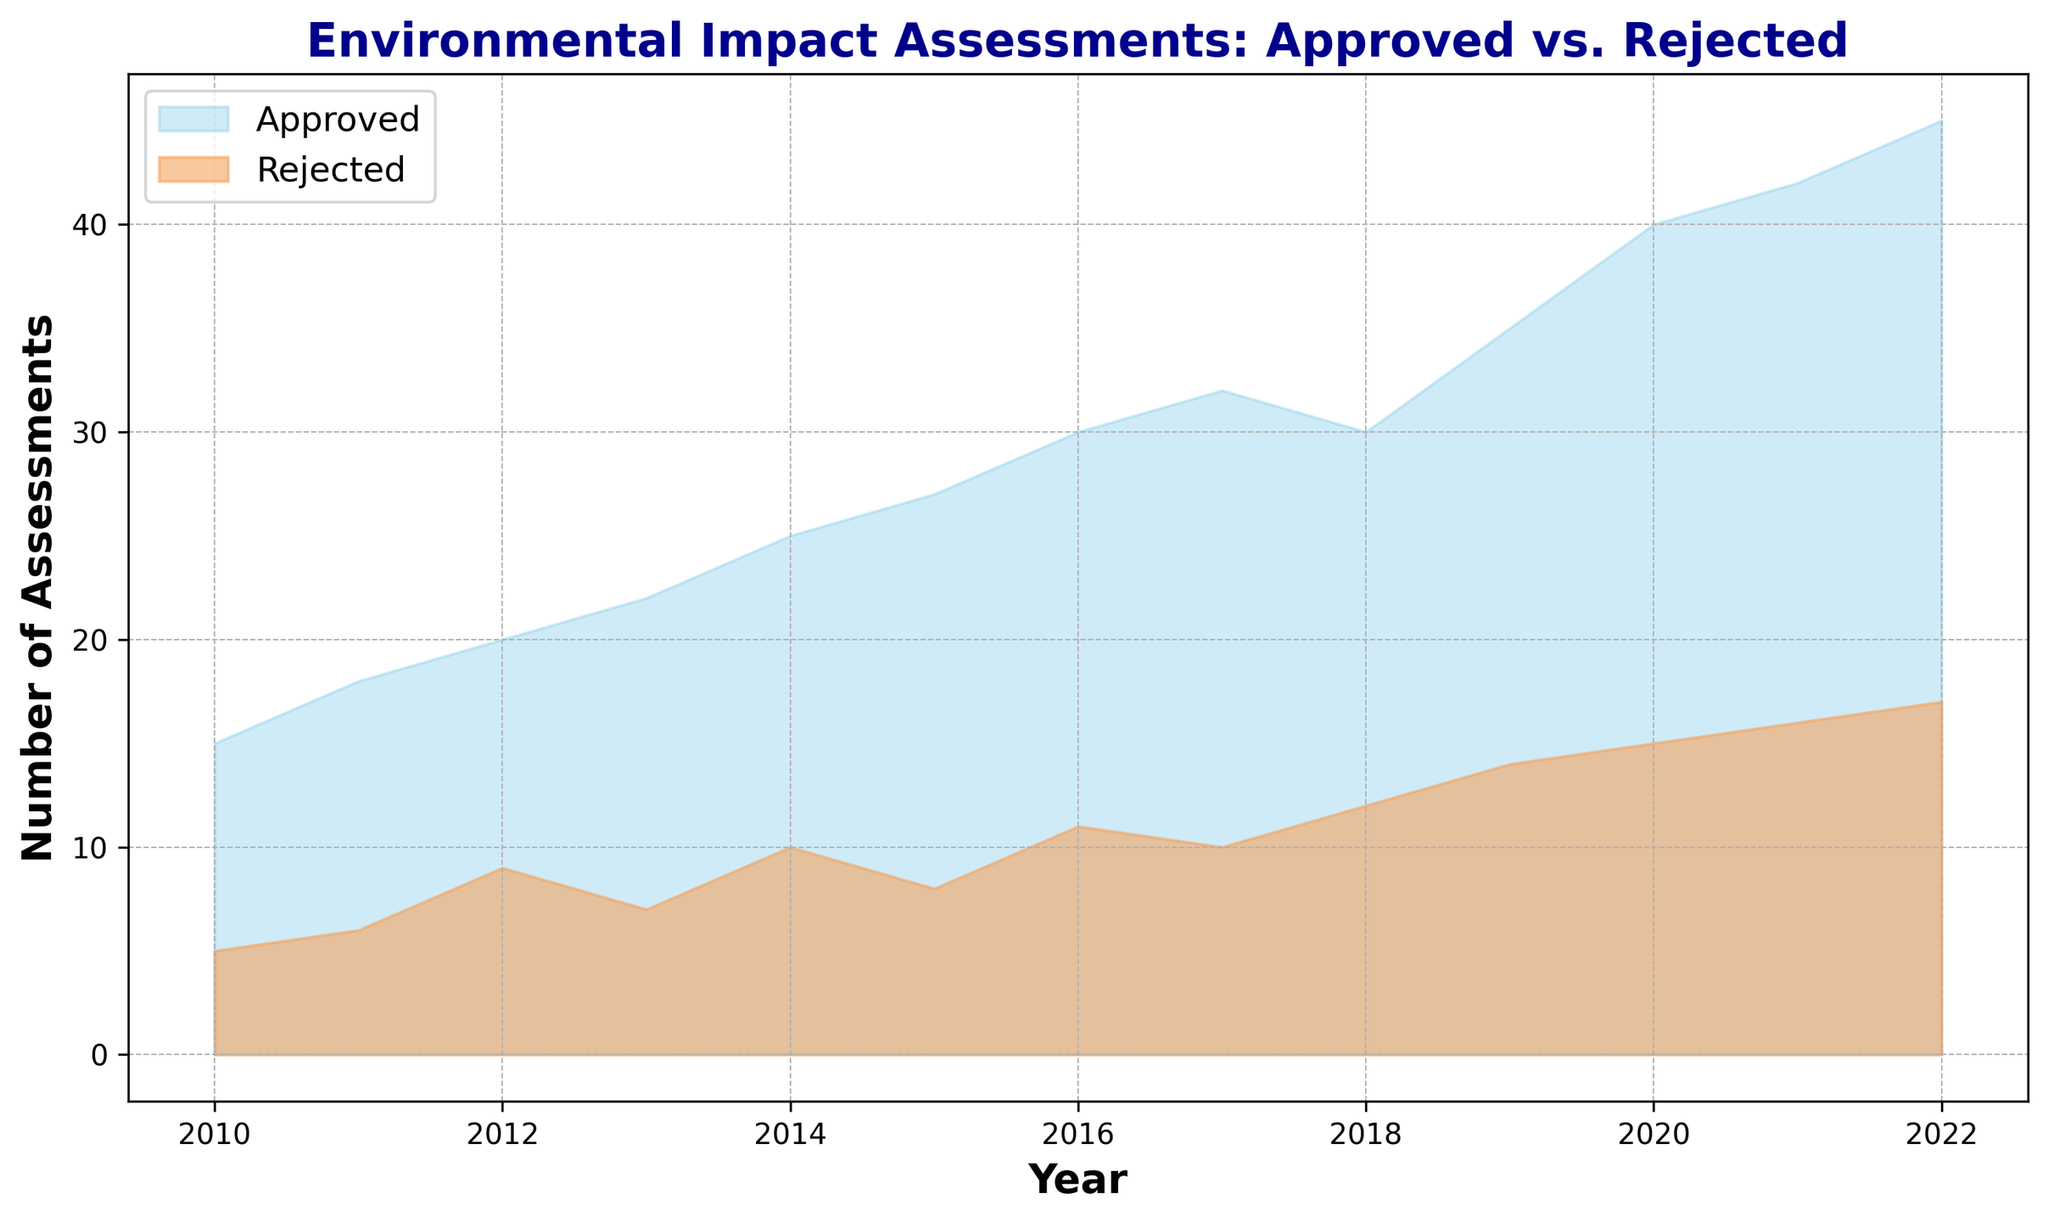How many assessments were approved and rejected in 2020? The figure shows the number of approved and rejected assessments for each year. For 2020, the approved assessments are 40, and the rejected assessments are 15.
Answer: 40 approved, 15 rejected In which year did the number of rejected assessments reach 10? By looking at the figure, we can see that the number of rejected assessments reached 10 in 2014 and again in 2017.
Answer: 2014 and 2017 Which year had the greatest increase in approved assessments compared to the previous year? To determine the greatest increase, we need to compare the difference in approved assessments between consecutive years. The year 2020 had the greatest increase with an additional 5 approved assessments compared to 2019 (40 - 35 = 5).
Answer: 2020 What is the trend in the number of approved assessments over the years? Observing the figure, the number of approved assessments shows a consistent upward trend from 2010 to 2022.
Answer: Upward trend Compare the number of approved and rejected assessments in 2015. Which is higher and by how much? In 2015, the number of approved assessments is 27, and the number of rejected assessments is 8. The difference is 27 - 8 = 19, so approved assessments are higher by 19.
Answer: Approved higher by 19 What is the average number of approved assessments from 2010 to 2022? Sum the approved assessments from 2010 to 2022 and then divide by the number of years. (15+18+20+22+25+27+30+32+30+35+40+42+45)/13 = 28.8
Answer: 28.8 Identify the year with the maximum number of rejected assessments and state the number. By examining the figure, we observe that the year 2022 has the maximum number of rejected assessments with 17 rejections.
Answer: 2022, 17 What is the combined total of approved and rejected assessments for the year 2018? Add the number of approved and rejected assessments for 2018, which are 30 and 12 respectively. So, 30 + 12 = 42.
Answer: 42 Did any year have the same number of approved and rejected assessments? By comparing the two lines in the figure for each year, there is no year in which the number of approved and rejected assessments is the same.
Answer: No 